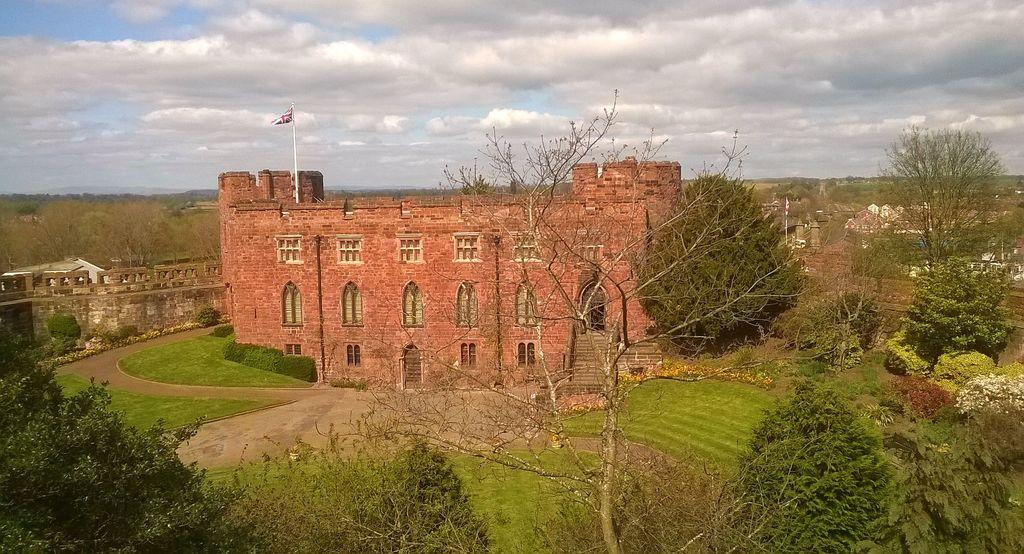What type of vegetation can be seen in the image? There are trees, grass, and plants in the image. What type of structure is present in the image? There is a building in the image. What architectural feature can be seen in the image? There is a wall in the image. What is attached to the wall in the image? There is a flag with a pole in the image. What part of the natural environment is visible in the image? The sky is visible in the image. What can be seen in the sky in the image? There are clouds in the sky. Where is the toothbrush located in the image? There is no toothbrush present in the image. What type of discovery can be seen in the image? There is no discovery depicted in the image; it features trees, grass, plants, a building, a wall, a flag with a pole, and clouds in the sky. 